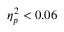<formula> <loc_0><loc_0><loc_500><loc_500>\eta _ { p } ^ { 2 } < 0 . 0 6</formula> 